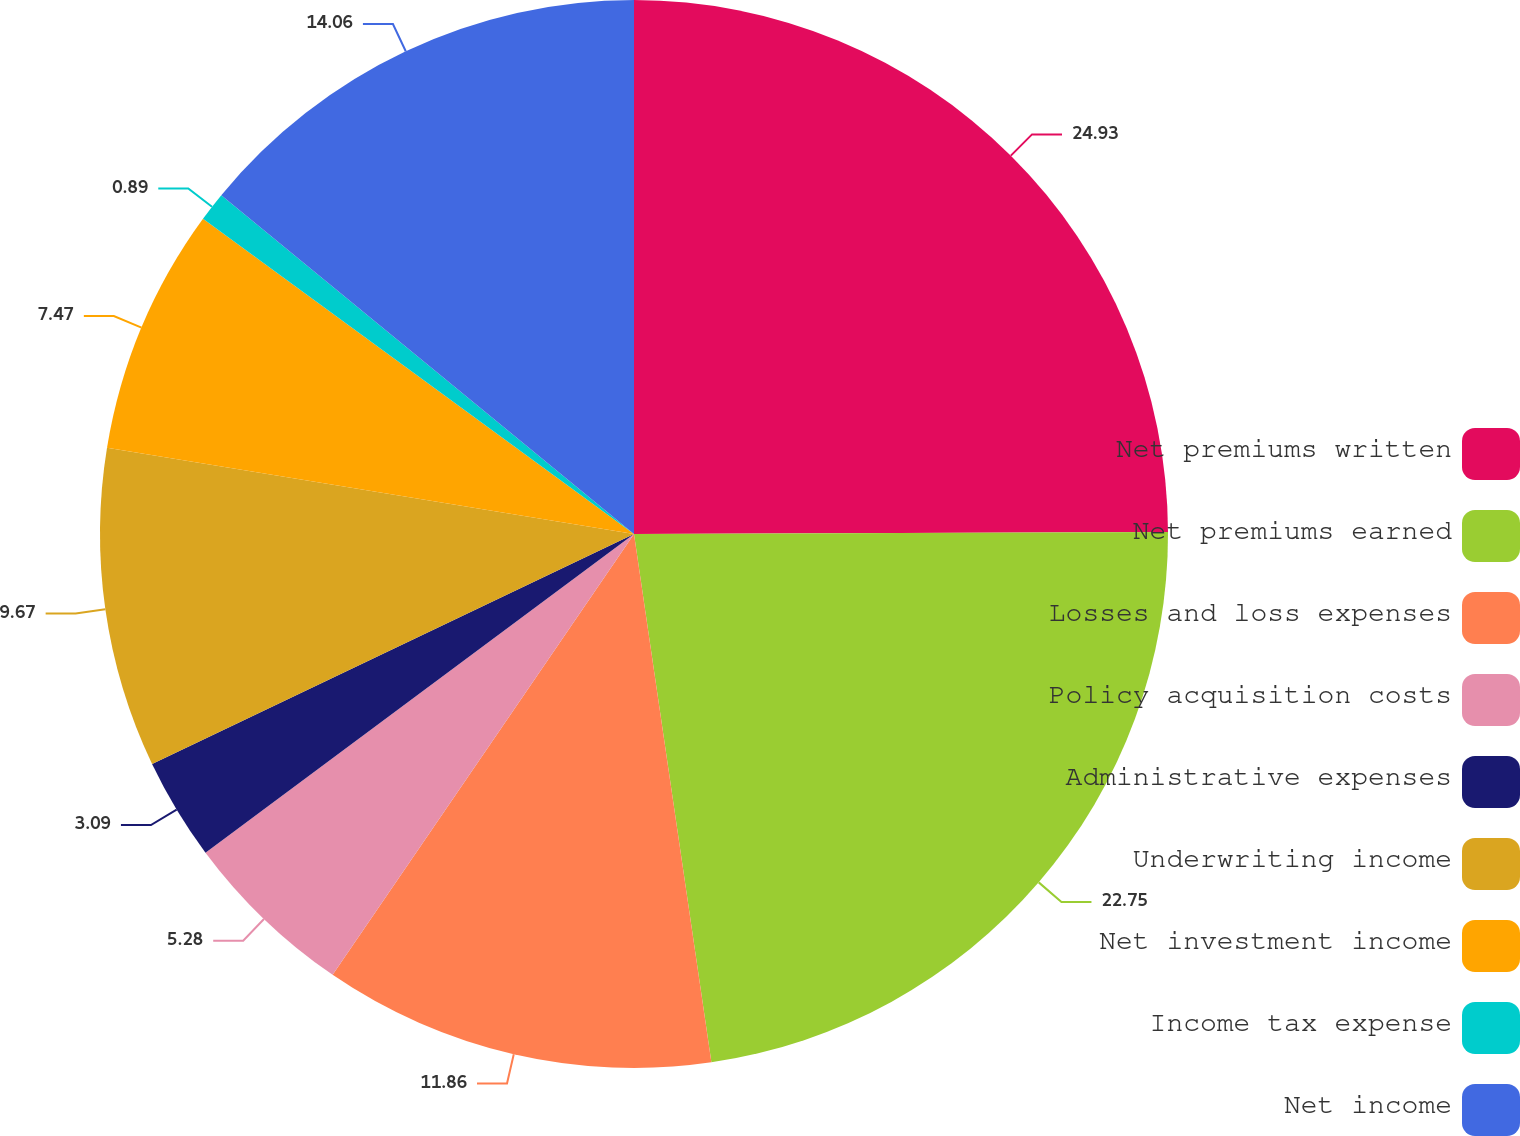Convert chart. <chart><loc_0><loc_0><loc_500><loc_500><pie_chart><fcel>Net premiums written<fcel>Net premiums earned<fcel>Losses and loss expenses<fcel>Policy acquisition costs<fcel>Administrative expenses<fcel>Underwriting income<fcel>Net investment income<fcel>Income tax expense<fcel>Net income<nl><fcel>24.94%<fcel>22.75%<fcel>11.86%<fcel>5.28%<fcel>3.09%<fcel>9.67%<fcel>7.47%<fcel>0.89%<fcel>14.06%<nl></chart> 